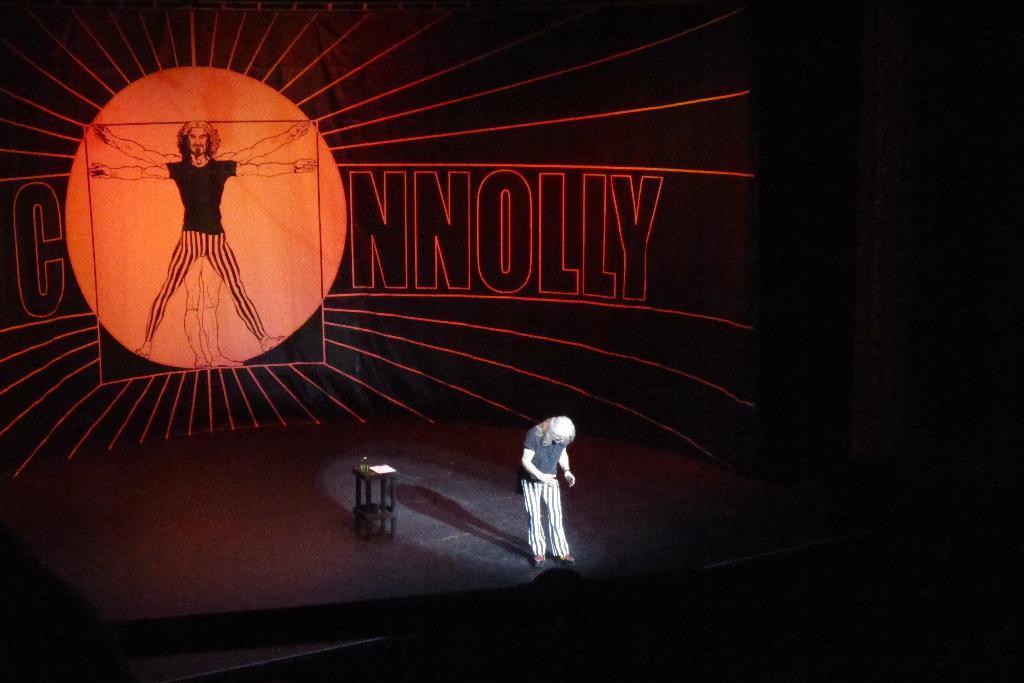In one or two sentences, can you explain what this image depicts? In this image, in the middle, we can see a person standing on the stage. In the background, we can see some pictures and text with light. On the right side, we can see black color. At the bottom, we can also see black color. 